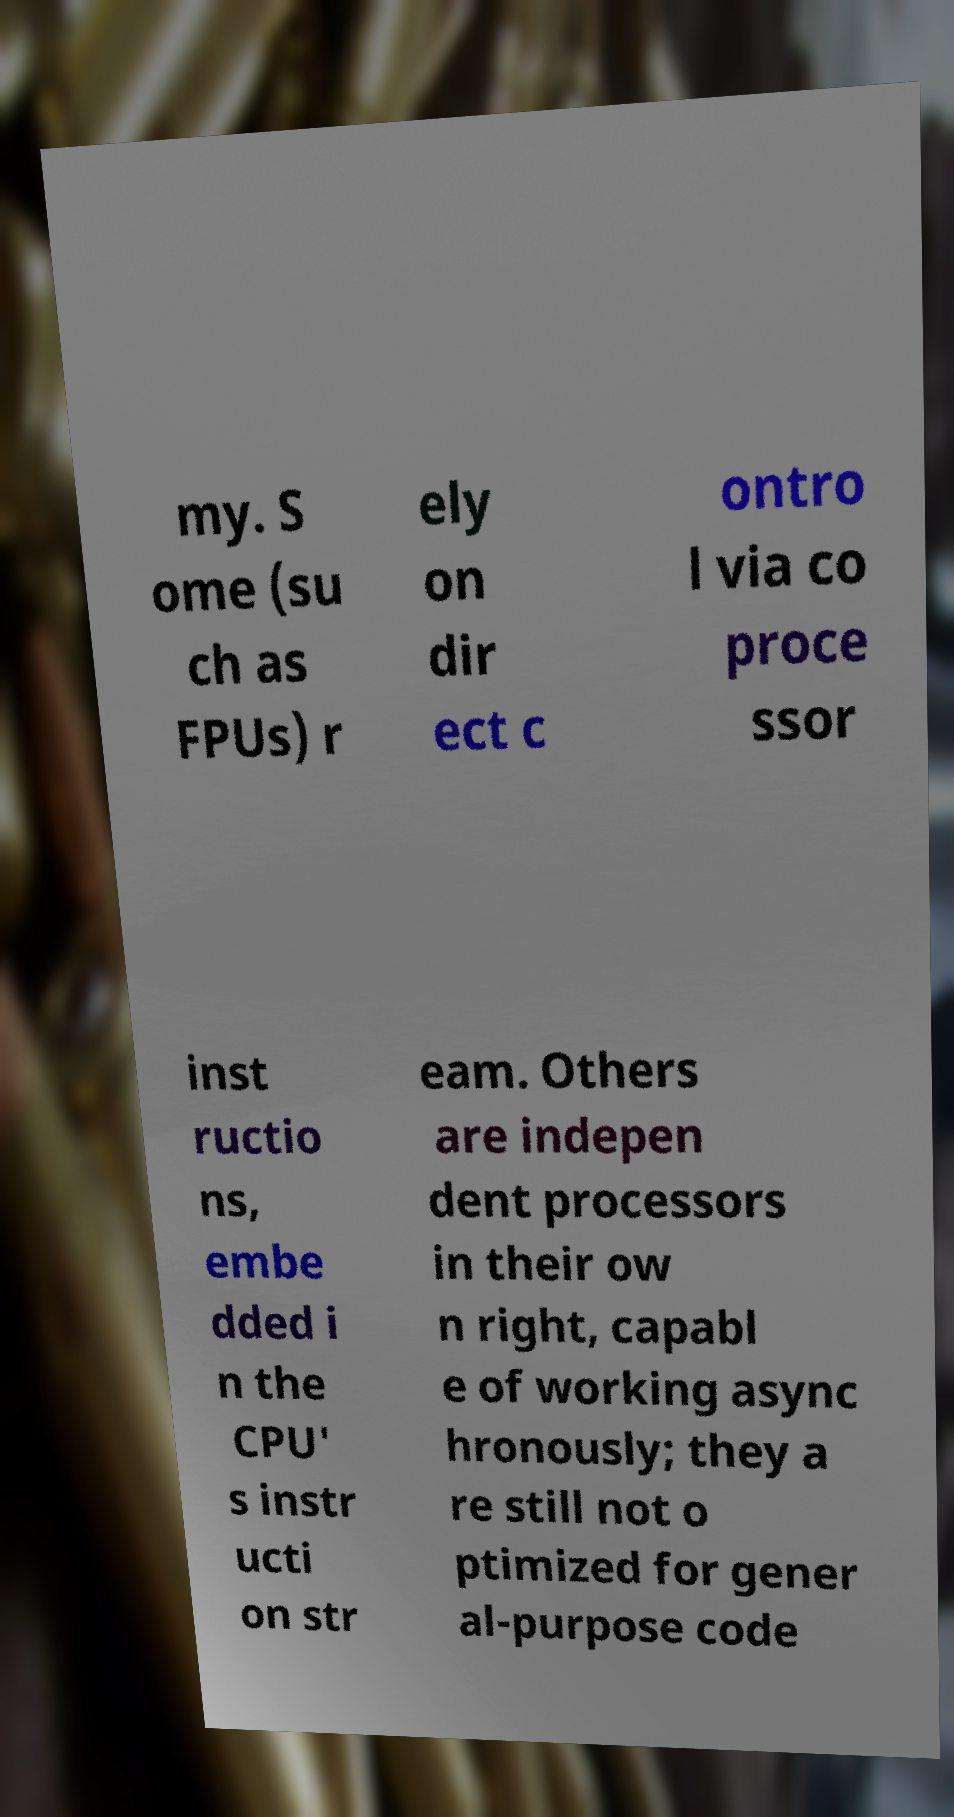Could you assist in decoding the text presented in this image and type it out clearly? my. S ome (su ch as FPUs) r ely on dir ect c ontro l via co proce ssor inst ructio ns, embe dded i n the CPU' s instr ucti on str eam. Others are indepen dent processors in their ow n right, capabl e of working async hronously; they a re still not o ptimized for gener al-purpose code 